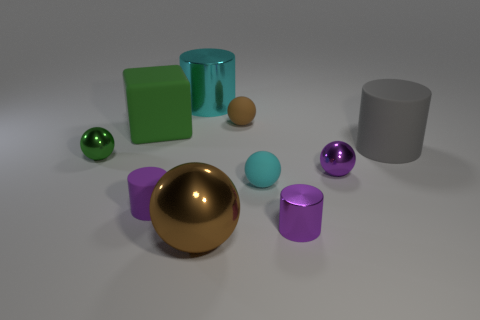What number of other objects are there of the same material as the tiny brown object?
Keep it short and to the point. 4. Do the small shiny thing that is to the left of the small brown rubber sphere and the cyan shiny object have the same shape?
Your response must be concise. No. How many small objects are either blue shiny cylinders or cyan balls?
Provide a short and direct response. 1. Are there the same number of tiny rubber spheres that are behind the purple metal sphere and brown metal objects that are behind the tiny cyan rubber sphere?
Your response must be concise. No. What number of other things are there of the same color as the tiny rubber cylinder?
Make the answer very short. 2. Is the color of the small matte cylinder the same as the matte sphere that is in front of the small purple sphere?
Ensure brevity in your answer.  No. How many red things are either large metallic cylinders or shiny spheres?
Your response must be concise. 0. Is the number of brown spheres on the left side of the big green cube the same as the number of large yellow matte things?
Provide a short and direct response. Yes. Is there any other thing that has the same size as the cyan rubber ball?
Provide a short and direct response. Yes. What color is the other matte thing that is the same shape as the purple matte object?
Offer a very short reply. Gray. 